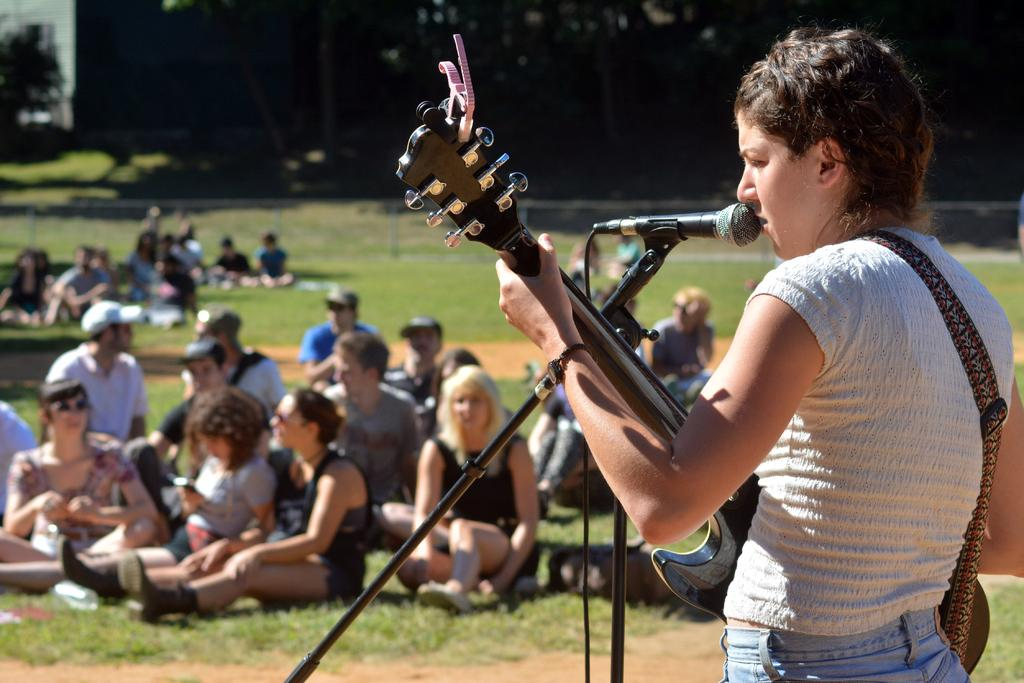What is the person on the right side of the image holding? The person is holding a guitar. What object is present in the image that is typically used for amplifying sound? There is a microphone in the image. What are the people on the grass in the image doing? The people sitting on the grass in the image. How many chickens can be seen grazing on the grass in the image? There are no chickens present in the image. What type of mint is being used as a garnish on the guitar in the image? There is no mint present in the image, and the guitar is not a food item. 